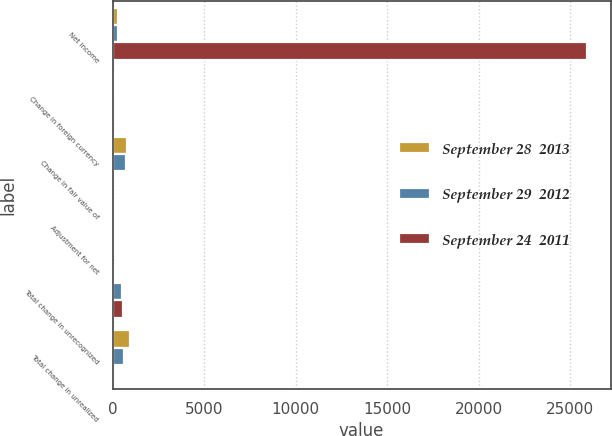<chart> <loc_0><loc_0><loc_500><loc_500><stacked_bar_chart><ecel><fcel>Net income<fcel>Change in foreign currency<fcel>Change in fair value of<fcel>Adjustment for net<fcel>Total change in unrecognized<fcel>Total change in unrealized<nl><fcel>September 28  2013<fcel>265<fcel>112<fcel>791<fcel>131<fcel>64<fcel>922<nl><fcel>September 29  2012<fcel>265<fcel>15<fcel>715<fcel>114<fcel>530<fcel>601<nl><fcel>September 24  2011<fcel>25922<fcel>12<fcel>29<fcel>70<fcel>542<fcel>41<nl></chart> 